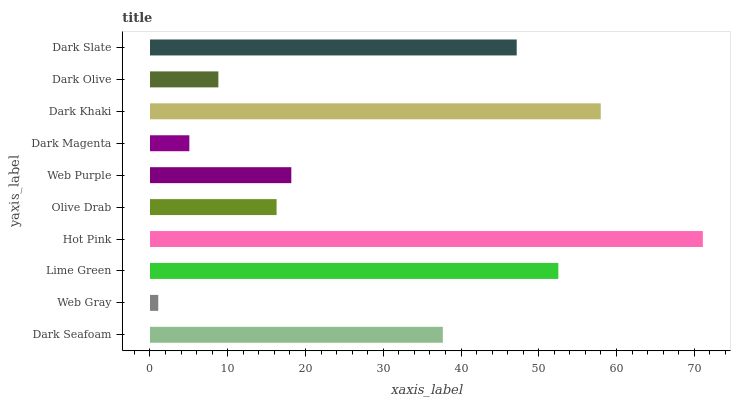Is Web Gray the minimum?
Answer yes or no. Yes. Is Hot Pink the maximum?
Answer yes or no. Yes. Is Lime Green the minimum?
Answer yes or no. No. Is Lime Green the maximum?
Answer yes or no. No. Is Lime Green greater than Web Gray?
Answer yes or no. Yes. Is Web Gray less than Lime Green?
Answer yes or no. Yes. Is Web Gray greater than Lime Green?
Answer yes or no. No. Is Lime Green less than Web Gray?
Answer yes or no. No. Is Dark Seafoam the high median?
Answer yes or no. Yes. Is Web Purple the low median?
Answer yes or no. Yes. Is Dark Olive the high median?
Answer yes or no. No. Is Lime Green the low median?
Answer yes or no. No. 